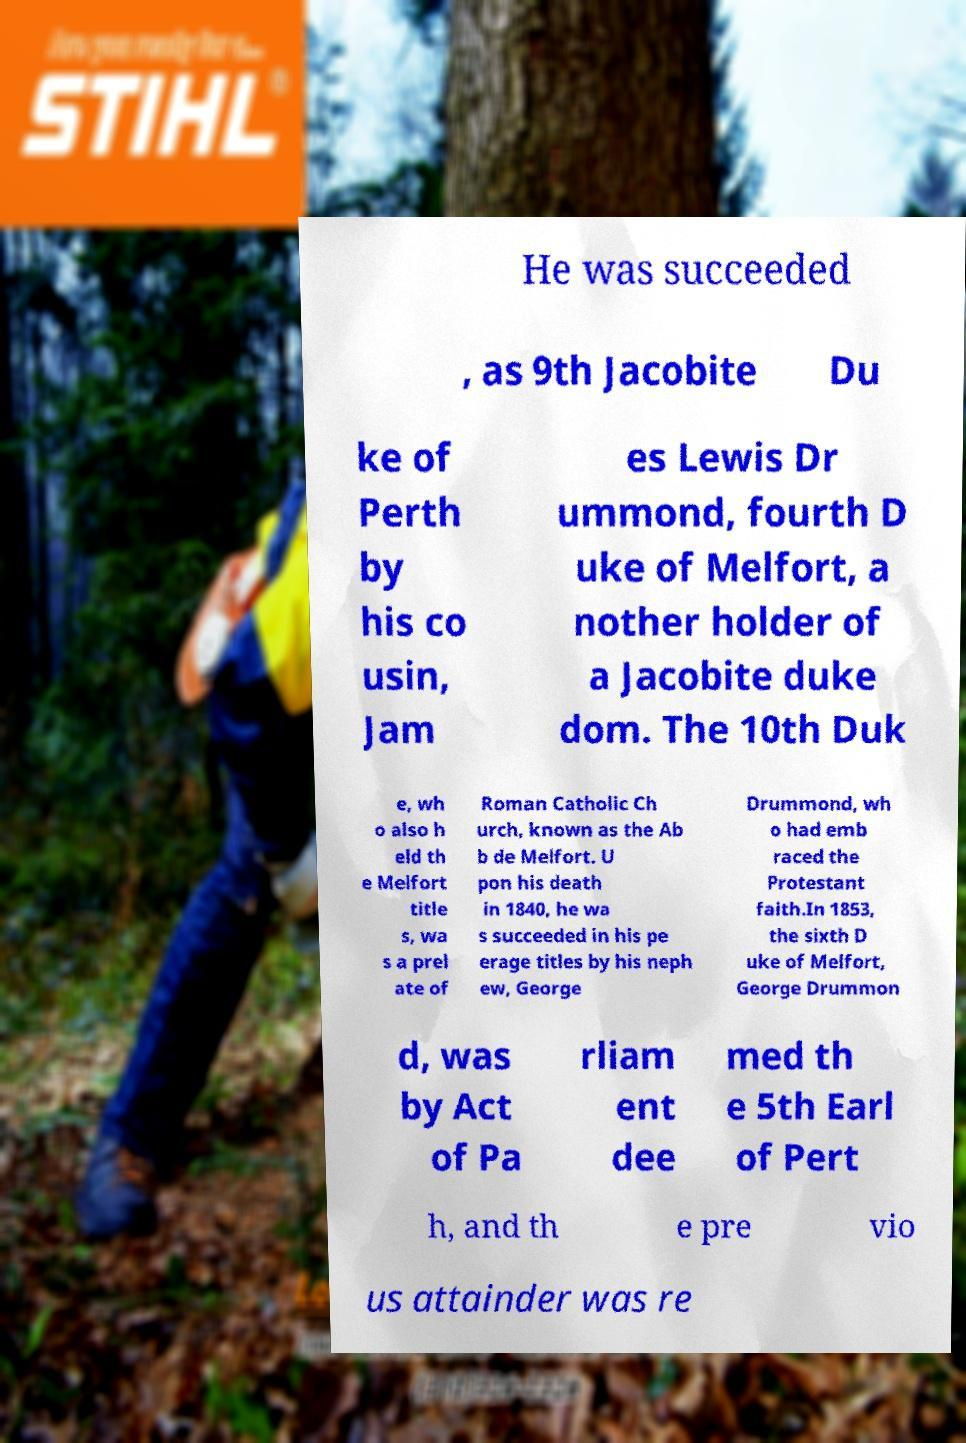Can you accurately transcribe the text from the provided image for me? He was succeeded , as 9th Jacobite Du ke of Perth by his co usin, Jam es Lewis Dr ummond, fourth D uke of Melfort, a nother holder of a Jacobite duke dom. The 10th Duk e, wh o also h eld th e Melfort title s, wa s a prel ate of Roman Catholic Ch urch, known as the Ab b de Melfort. U pon his death in 1840, he wa s succeeded in his pe erage titles by his neph ew, George Drummond, wh o had emb raced the Protestant faith.In 1853, the sixth D uke of Melfort, George Drummon d, was by Act of Pa rliam ent dee med th e 5th Earl of Pert h, and th e pre vio us attainder was re 